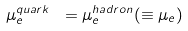<formula> <loc_0><loc_0><loc_500><loc_500>\mu _ { e } ^ { q u a r k } \ = \mu _ { e } ^ { h a d r o n } ( \equiv \mu _ { e } )</formula> 